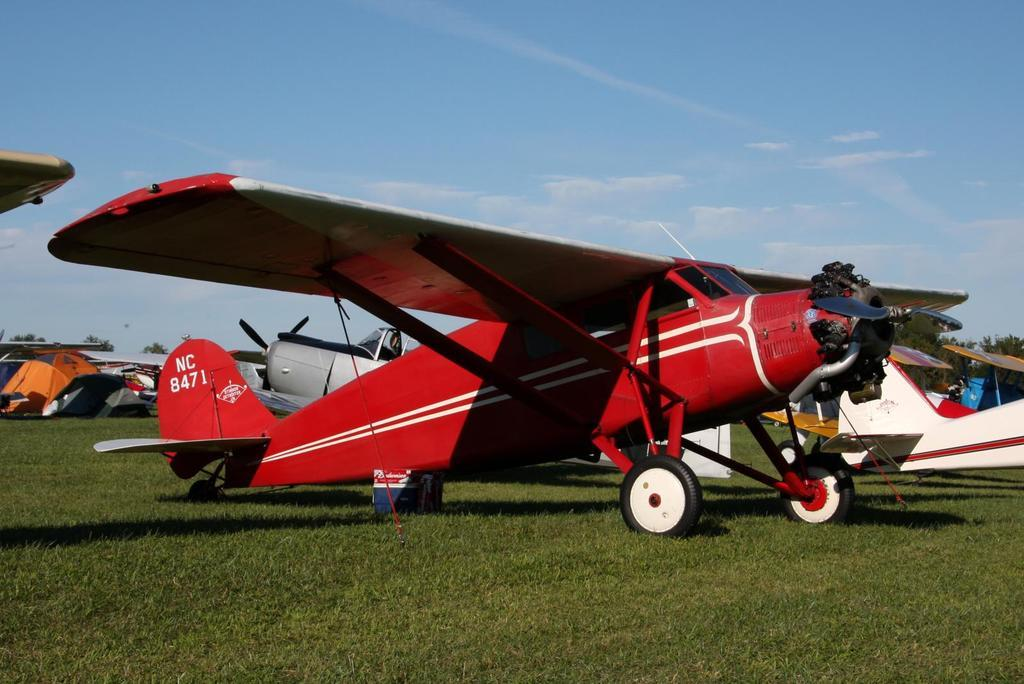What is the color of the flight visible on the ground in the image? There is a red color flight visible on the ground in the image. What can be seen on the right side of the image? There is an aircraft on the right side of the image. What is visible at the top of the image? The sky is visible at the top of the image. How many girls are sitting on the aircraft in the image? There are no girls present in the image; it features an aircraft and a red color flight on the ground. Is there an owl visible in the image? There is no owl present in the image. 